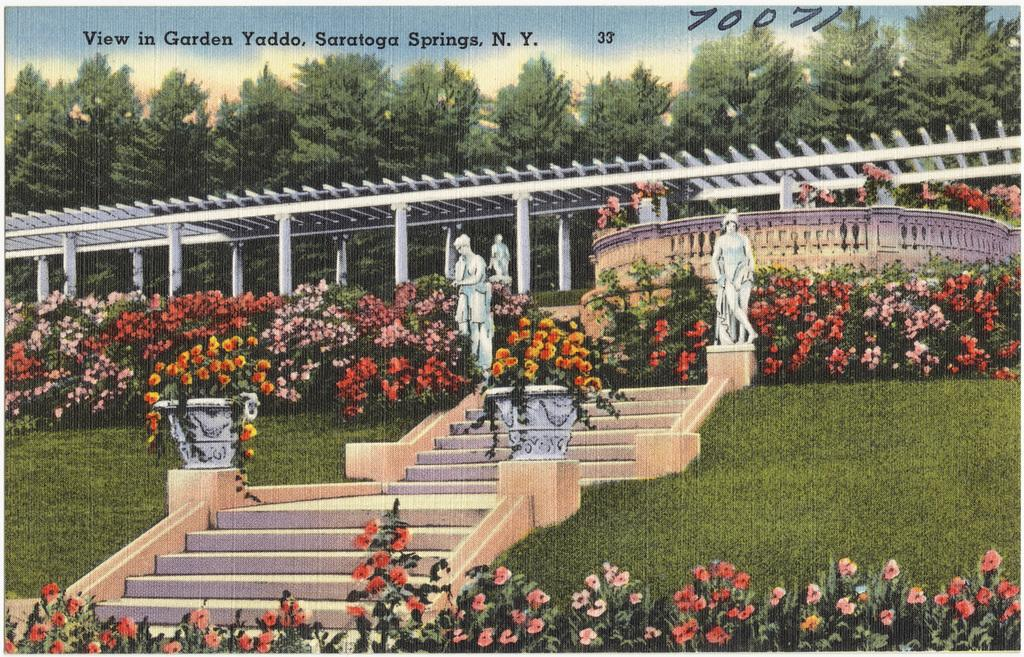<image>
Write a terse but informative summary of the picture. A view of flowers and statues in the Garden Yaddo from New York. 